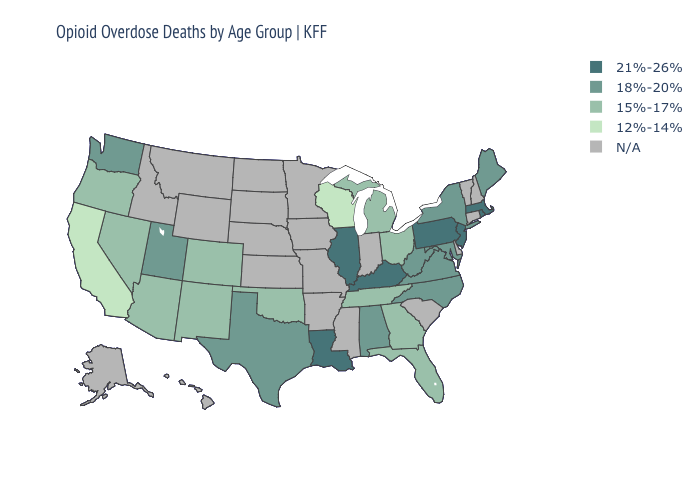What is the value of Utah?
Give a very brief answer. 18%-20%. Which states have the lowest value in the USA?
Answer briefly. California, Wisconsin. Among the states that border Ohio , does West Virginia have the lowest value?
Write a very short answer. No. What is the value of Montana?
Answer briefly. N/A. Among the states that border New Jersey , which have the lowest value?
Be succinct. New York. Name the states that have a value in the range 21%-26%?
Write a very short answer. Illinois, Kentucky, Louisiana, Massachusetts, New Jersey, Pennsylvania, Rhode Island. Which states hav the highest value in the West?
Give a very brief answer. Utah, Washington. Name the states that have a value in the range 12%-14%?
Short answer required. California, Wisconsin. Which states have the lowest value in the Northeast?
Give a very brief answer. Maine, New York. Among the states that border Wisconsin , does Illinois have the highest value?
Write a very short answer. Yes. Does the first symbol in the legend represent the smallest category?
Quick response, please. No. Does New Jersey have the lowest value in the USA?
Short answer required. No. Among the states that border Connecticut , does New York have the lowest value?
Concise answer only. Yes. 